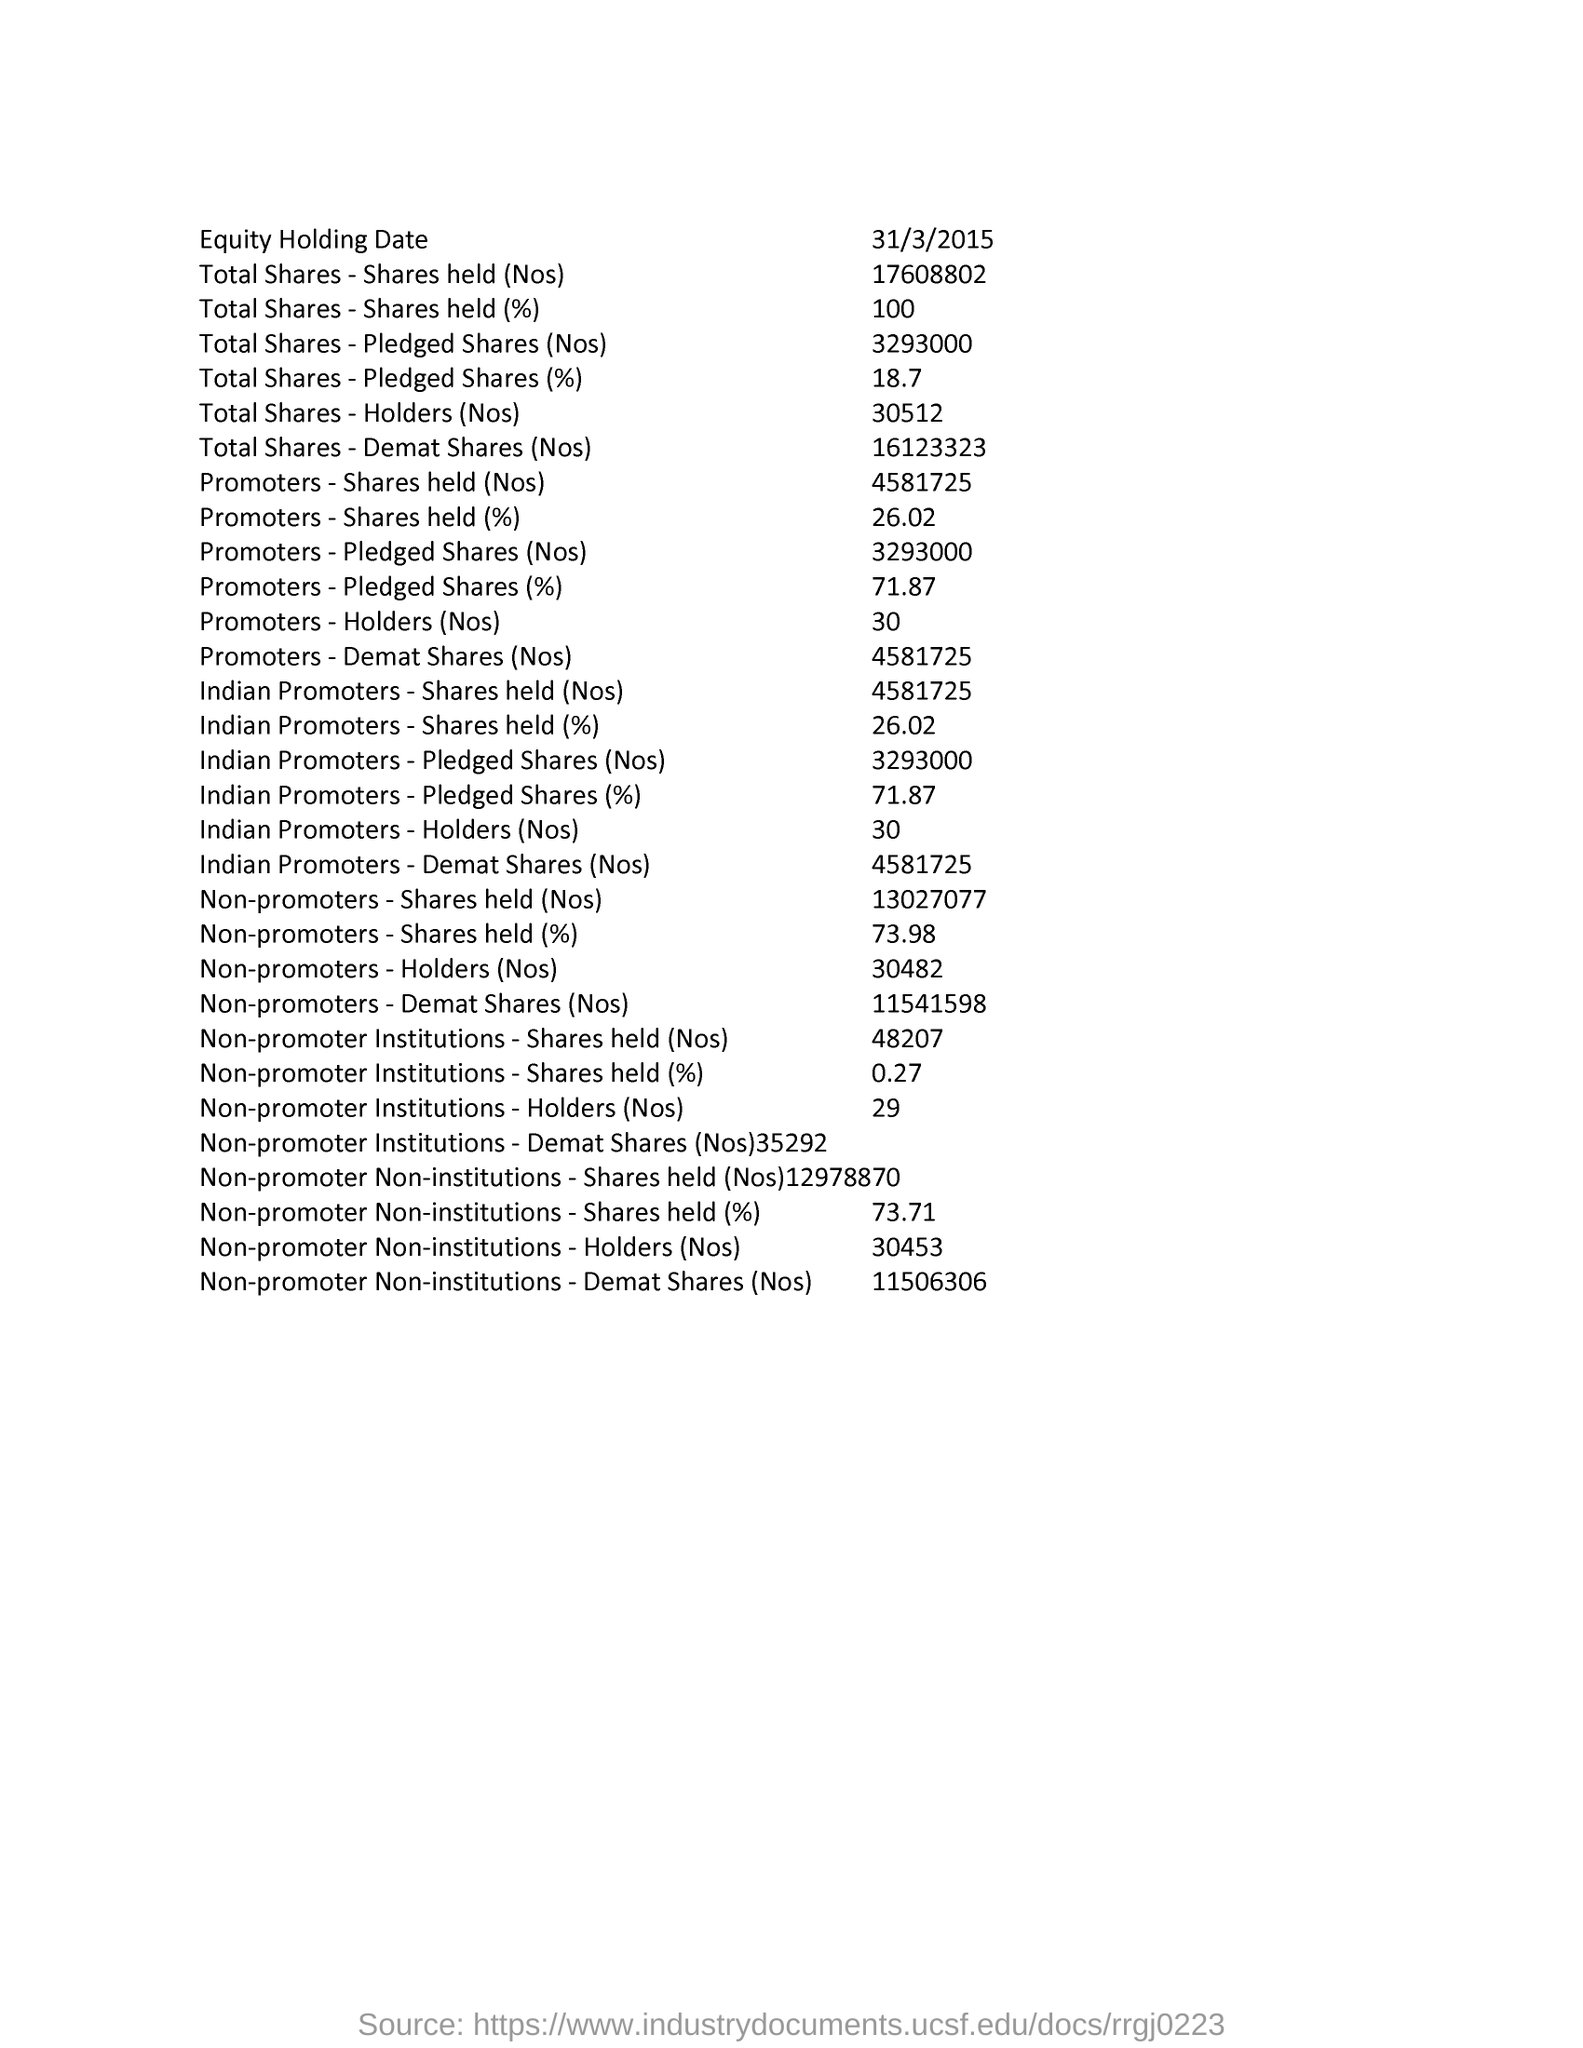What is the Equity Holding Date ?
Provide a short and direct response. 31/3/2015. 